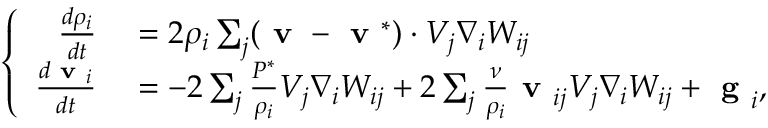<formula> <loc_0><loc_0><loc_500><loc_500>\left \{ \begin{array} { r l } { \frac { d \rho _ { i } } { d t } } & = 2 { \rho _ { i } } \sum _ { j } ( v - v ^ { * } ) \cdot V _ { j } \nabla _ { i } W _ { i j } } \\ { \frac { d v _ { i } } { d t } } & = - 2 \sum _ { j } \frac { { P } ^ { * } } { \rho _ { i } } V _ { j } \nabla _ { i } W _ { i j } + 2 \sum _ { j } \frac { \nu } { \rho _ { i } } v _ { i j } V _ { j } \nabla _ { i } W _ { i j } + g _ { i } , } \end{array}</formula> 